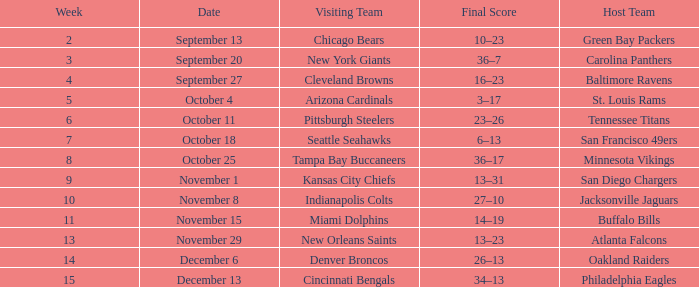Which week did the Baltimore Ravens play at home ? 4.0. 